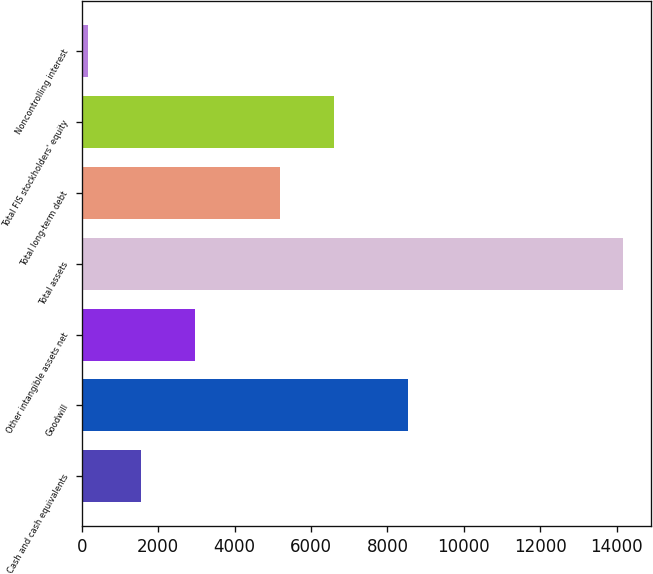<chart> <loc_0><loc_0><loc_500><loc_500><bar_chart><fcel>Cash and cash equivalents<fcel>Goodwill<fcel>Other intangible assets net<fcel>Total assets<fcel>Total long-term debt<fcel>Total FIS stockholders' equity<fcel>Noncontrolling interest<nl><fcel>1560.19<fcel>8550<fcel>2961.98<fcel>14176.3<fcel>5192.1<fcel>6593.89<fcel>158.4<nl></chart> 